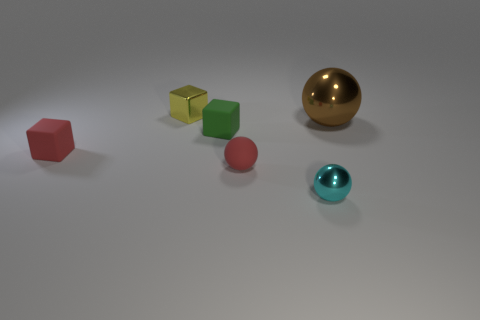Add 1 big cyan metal objects. How many objects exist? 7 Subtract all tiny blocks. Subtract all tiny red objects. How many objects are left? 1 Add 6 small spheres. How many small spheres are left? 8 Add 1 small yellow cubes. How many small yellow cubes exist? 2 Subtract 0 cyan cubes. How many objects are left? 6 